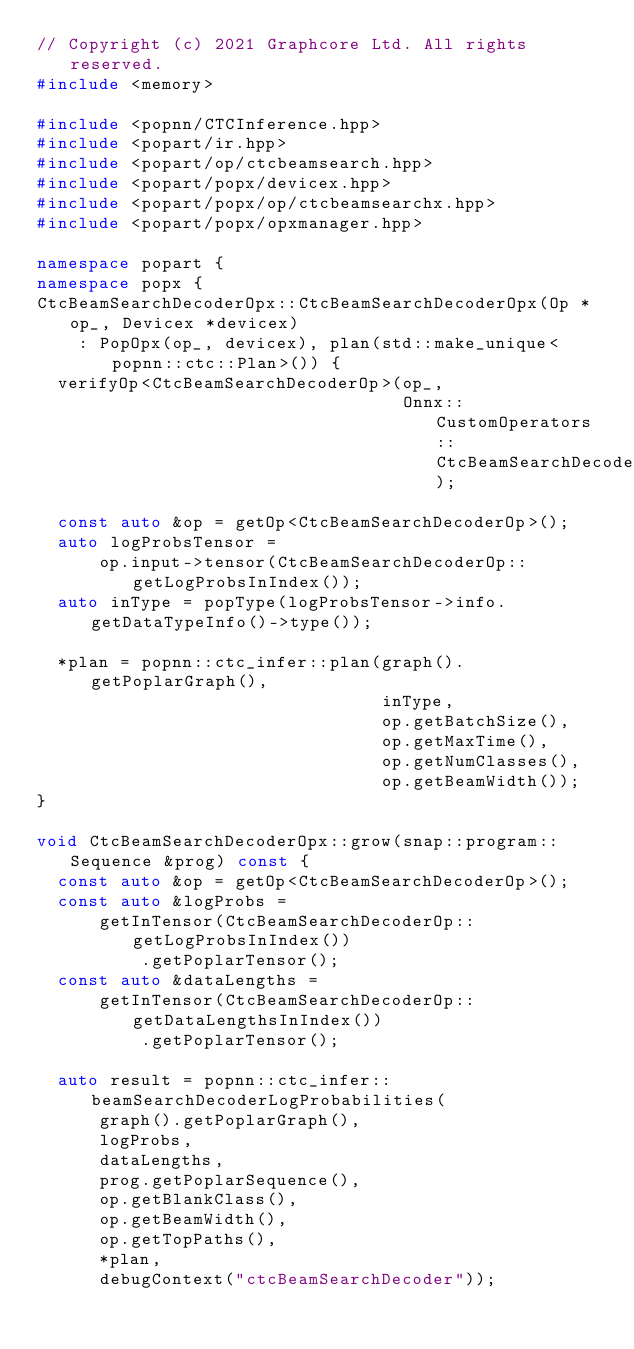Convert code to text. <code><loc_0><loc_0><loc_500><loc_500><_C++_>// Copyright (c) 2021 Graphcore Ltd. All rights reserved.
#include <memory>

#include <popnn/CTCInference.hpp>
#include <popart/ir.hpp>
#include <popart/op/ctcbeamsearch.hpp>
#include <popart/popx/devicex.hpp>
#include <popart/popx/op/ctcbeamsearchx.hpp>
#include <popart/popx/opxmanager.hpp>

namespace popart {
namespace popx {
CtcBeamSearchDecoderOpx::CtcBeamSearchDecoderOpx(Op *op_, Devicex *devicex)
    : PopOpx(op_, devicex), plan(std::make_unique<popnn::ctc::Plan>()) {
  verifyOp<CtcBeamSearchDecoderOp>(op_,
                                   Onnx::CustomOperators::CtcBeamSearchDecoder);

  const auto &op = getOp<CtcBeamSearchDecoderOp>();
  auto logProbsTensor =
      op.input->tensor(CtcBeamSearchDecoderOp::getLogProbsInIndex());
  auto inType = popType(logProbsTensor->info.getDataTypeInfo()->type());

  *plan = popnn::ctc_infer::plan(graph().getPoplarGraph(),
                                 inType,
                                 op.getBatchSize(),
                                 op.getMaxTime(),
                                 op.getNumClasses(),
                                 op.getBeamWidth());
}

void CtcBeamSearchDecoderOpx::grow(snap::program::Sequence &prog) const {
  const auto &op = getOp<CtcBeamSearchDecoderOp>();
  const auto &logProbs =
      getInTensor(CtcBeamSearchDecoderOp::getLogProbsInIndex())
          .getPoplarTensor();
  const auto &dataLengths =
      getInTensor(CtcBeamSearchDecoderOp::getDataLengthsInIndex())
          .getPoplarTensor();

  auto result = popnn::ctc_infer::beamSearchDecoderLogProbabilities(
      graph().getPoplarGraph(),
      logProbs,
      dataLengths,
      prog.getPoplarSequence(),
      op.getBlankClass(),
      op.getBeamWidth(),
      op.getTopPaths(),
      *plan,
      debugContext("ctcBeamSearchDecoder"));
</code> 